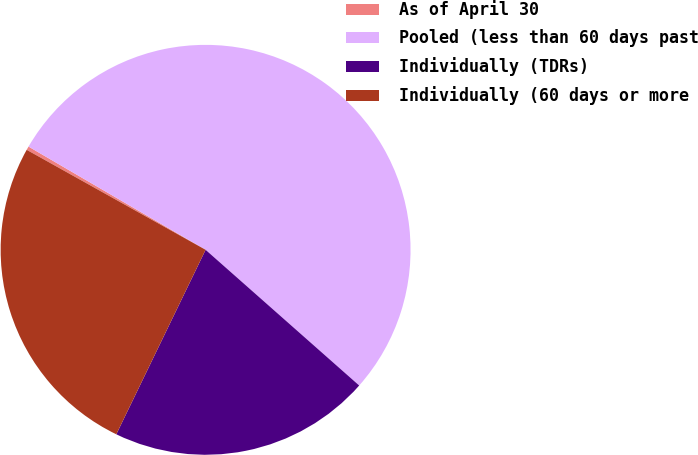Convert chart to OTSL. <chart><loc_0><loc_0><loc_500><loc_500><pie_chart><fcel>As of April 30<fcel>Pooled (less than 60 days past<fcel>Individually (TDRs)<fcel>Individually (60 days or more<nl><fcel>0.29%<fcel>53.12%<fcel>20.66%<fcel>25.94%<nl></chart> 